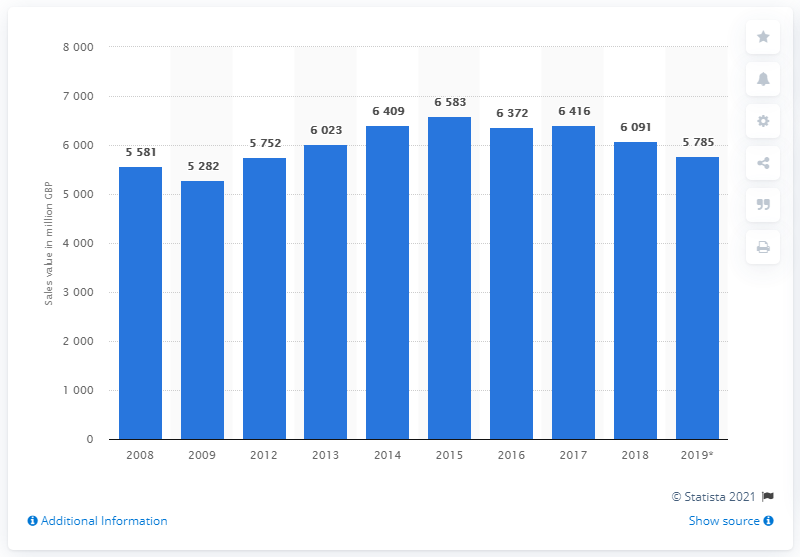Draw attention to some important aspects in this diagram. Bread and fresh pastry were last sold in the UK in 2008. In the UK in 2019, the value of bread and fresh pastry was 5,785. 